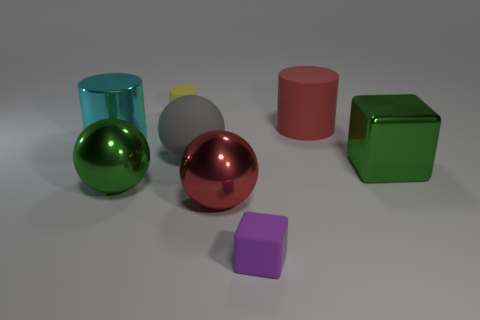Add 2 cylinders. How many objects exist? 10 Subtract all blocks. How many objects are left? 6 Add 4 gray things. How many gray things exist? 5 Subtract 0 gray blocks. How many objects are left? 8 Subtract all large cyan rubber things. Subtract all large red balls. How many objects are left? 7 Add 6 big gray rubber spheres. How many big gray rubber spheres are left? 7 